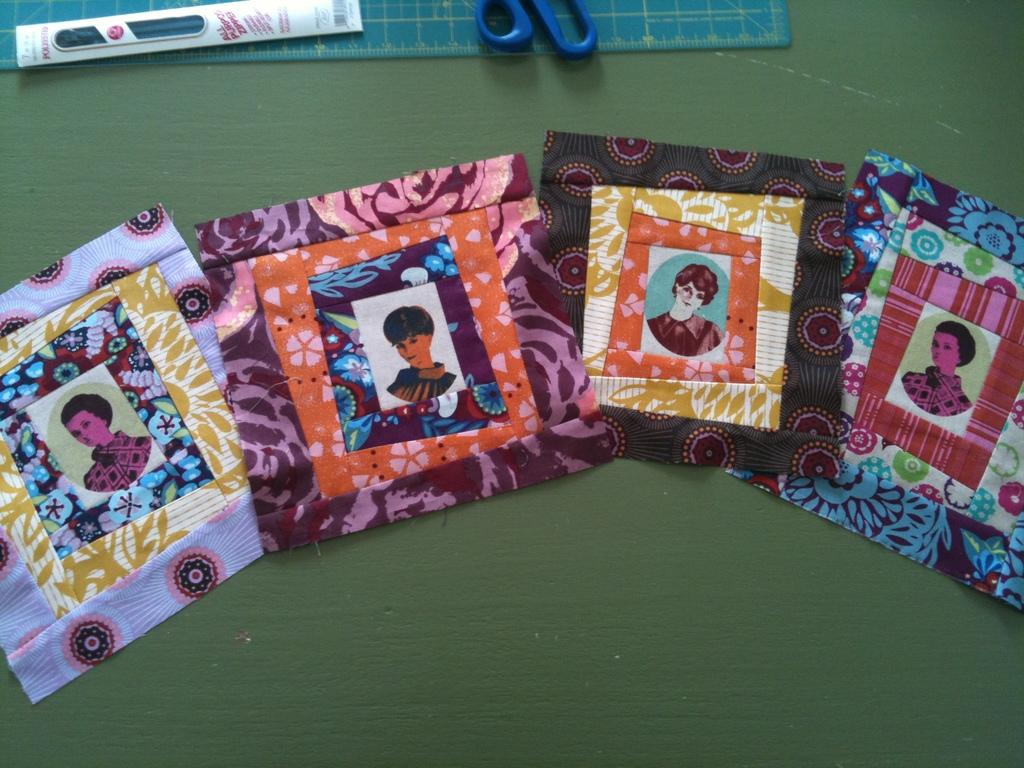What is depicted on the clothes in the image? There are photos of a group of people on the clothes. What tool is visible in the image? There is a scissor in the image. What instrument is present in the image for measuring weight? There is a scale in the image. What writing instrument is visible in the image? There is a pen in the image. How many members of the team are wearing a veil in the image? There is no team or veil present in the image; it features photos of a group of people on clothes, a scissor, a scale, and a pen. What is the stomach size of the person in the image? There is no person or stomach size mentioned in the image; it only shows photos of a group of people on clothes, a scissor, a scale, and a pen. 